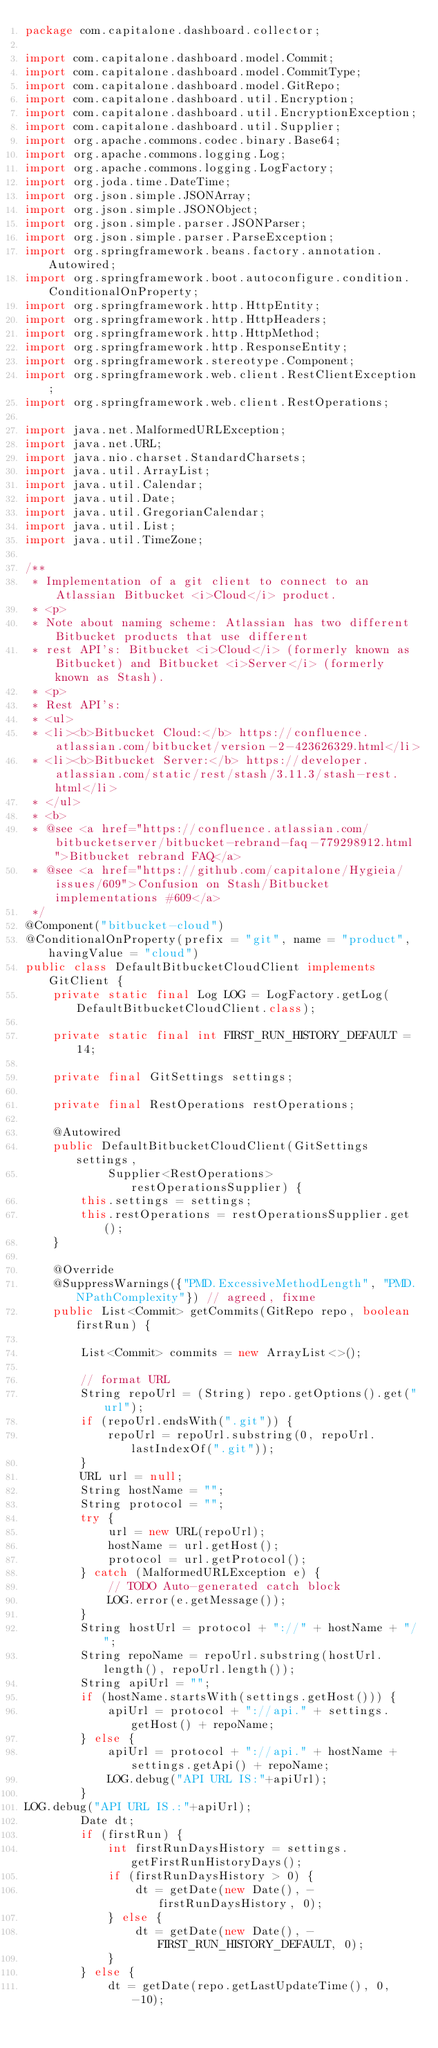<code> <loc_0><loc_0><loc_500><loc_500><_Java_>package com.capitalone.dashboard.collector;

import com.capitalone.dashboard.model.Commit;
import com.capitalone.dashboard.model.CommitType;
import com.capitalone.dashboard.model.GitRepo;
import com.capitalone.dashboard.util.Encryption;
import com.capitalone.dashboard.util.EncryptionException;
import com.capitalone.dashboard.util.Supplier;
import org.apache.commons.codec.binary.Base64;
import org.apache.commons.logging.Log;
import org.apache.commons.logging.LogFactory;
import org.joda.time.DateTime;
import org.json.simple.JSONArray;
import org.json.simple.JSONObject;
import org.json.simple.parser.JSONParser;
import org.json.simple.parser.ParseException;
import org.springframework.beans.factory.annotation.Autowired;
import org.springframework.boot.autoconfigure.condition.ConditionalOnProperty;
import org.springframework.http.HttpEntity;
import org.springframework.http.HttpHeaders;
import org.springframework.http.HttpMethod;
import org.springframework.http.ResponseEntity;
import org.springframework.stereotype.Component;
import org.springframework.web.client.RestClientException;
import org.springframework.web.client.RestOperations;

import java.net.MalformedURLException;
import java.net.URL;
import java.nio.charset.StandardCharsets;
import java.util.ArrayList;
import java.util.Calendar;
import java.util.Date;
import java.util.GregorianCalendar;
import java.util.List;
import java.util.TimeZone;

/**
 * Implementation of a git client to connect to an Atlassian Bitbucket <i>Cloud</i> product. 
 * <p>
 * Note about naming scheme: Atlassian has two different Bitbucket products that use different
 * rest API's: Bitbucket <i>Cloud</i> (formerly known as Bitbucket) and Bitbucket <i>Server</i> (formerly known as Stash).
 * <p>
 * Rest API's:
 * <ul>
 * <li><b>Bitbucket Cloud:</b> https://confluence.atlassian.com/bitbucket/version-2-423626329.html</li>
 * <li><b>Bitbucket Server:</b> https://developer.atlassian.com/static/rest/stash/3.11.3/stash-rest.html</li>
 * </ul>
 * <b>
 * @see <a href="https://confluence.atlassian.com/bitbucketserver/bitbucket-rebrand-faq-779298912.html">Bitbucket rebrand FAQ</a>
 * @see <a href="https://github.com/capitalone/Hygieia/issues/609">Confusion on Stash/Bitbucket implementations #609</a>
 */
@Component("bitbucket-cloud")
@ConditionalOnProperty(prefix = "git", name = "product", havingValue = "cloud")
public class DefaultBitbucketCloudClient implements GitClient {
	private static final Log LOG = LogFactory.getLog(DefaultBitbucketCloudClient.class);

	private static final int FIRST_RUN_HISTORY_DEFAULT = 14;

	private final GitSettings settings;

	private final RestOperations restOperations;

	@Autowired
	public DefaultBitbucketCloudClient(GitSettings settings,
			Supplier<RestOperations> restOperationsSupplier) {
		this.settings = settings;
		this.restOperations = restOperationsSupplier.get();
	}

	@Override
	@SuppressWarnings({"PMD.ExcessiveMethodLength", "PMD.NPathComplexity"}) // agreed, fixme
	public List<Commit> getCommits(GitRepo repo, boolean firstRun) {

		List<Commit> commits = new ArrayList<>();

		// format URL
		String repoUrl = (String) repo.getOptions().get("url");
		if (repoUrl.endsWith(".git")) {
			repoUrl = repoUrl.substring(0, repoUrl.lastIndexOf(".git"));
		}
		URL url = null;
		String hostName = "";
		String protocol = "";
		try {
			url = new URL(repoUrl);
			hostName = url.getHost();
			protocol = url.getProtocol();
		} catch (MalformedURLException e) {
			// TODO Auto-generated catch block
			LOG.error(e.getMessage());
		}
		String hostUrl = protocol + "://" + hostName + "/";
		String repoName = repoUrl.substring(hostUrl.length(), repoUrl.length());
		String apiUrl = "";
		if (hostName.startsWith(settings.getHost())) {
			apiUrl = protocol + "://api." + settings.getHost() + repoName;
		} else {
			apiUrl = protocol + "://api." + hostName + settings.getApi() + repoName;
			LOG.debug("API URL IS:"+apiUrl);
		}
LOG.debug("API URL IS.:"+apiUrl);
		Date dt;
		if (firstRun) {
			int firstRunDaysHistory = settings.getFirstRunHistoryDays();
			if (firstRunDaysHistory > 0) {
				dt = getDate(new Date(), -firstRunDaysHistory, 0);
			} else {
				dt = getDate(new Date(), -FIRST_RUN_HISTORY_DEFAULT, 0);
			}
		} else {
			dt = getDate(repo.getLastUpdateTime(), 0, -10);</code> 